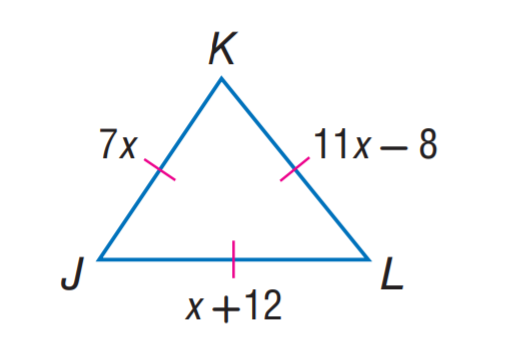Answer the mathemtical geometry problem and directly provide the correct option letter.
Question: Find K L.
Choices: A: 7 B: 11 C: 12 D: 14 D 